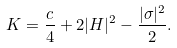Convert formula to latex. <formula><loc_0><loc_0><loc_500><loc_500>K = \frac { c } { 4 } + 2 | H | ^ { 2 } - \frac { | \sigma | ^ { 2 } } { 2 } .</formula> 